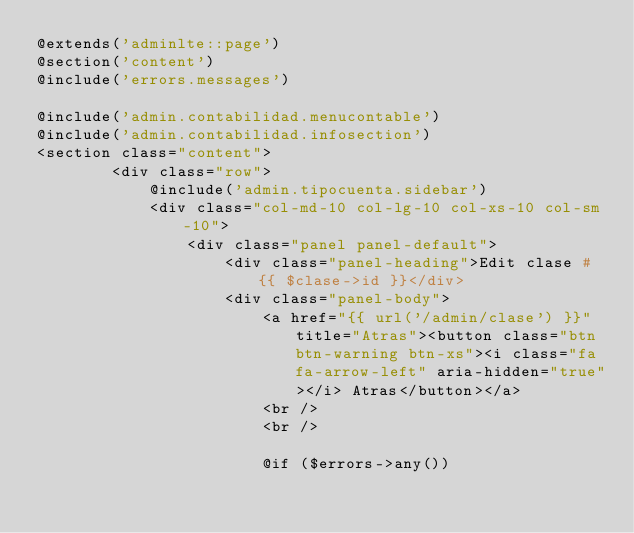<code> <loc_0><loc_0><loc_500><loc_500><_PHP_>@extends('adminlte::page')
@section('content')
@include('errors.messages')

@include('admin.contabilidad.menucontable')
@include('admin.contabilidad.infosection')
<section class="content">
        <div class="row">
            @include('admin.tipocuenta.sidebar')
            <div class="col-md-10 col-lg-10 col-xs-10 col-sm-10">
                <div class="panel panel-default">
                    <div class="panel-heading">Edit clase #{{ $clase->id }}</div>
                    <div class="panel-body">
                        <a href="{{ url('/admin/clase') }}" title="Atras"><button class="btn btn-warning btn-xs"><i class="fa fa-arrow-left" aria-hidden="true"></i> Atras</button></a>
                        <br />
                        <br />

                        @if ($errors->any())</code> 